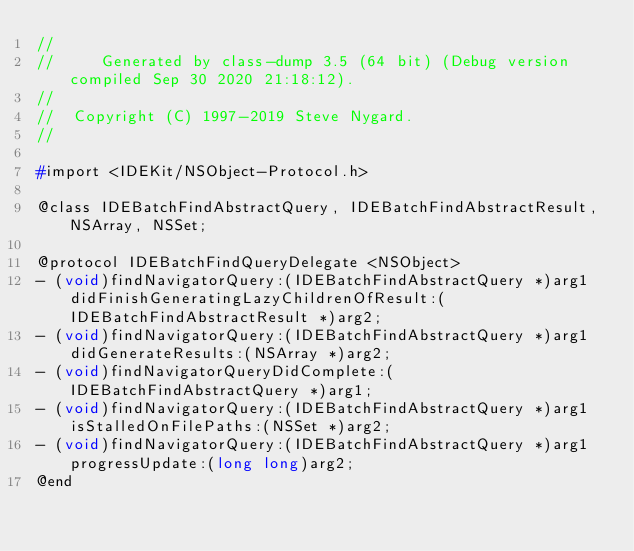Convert code to text. <code><loc_0><loc_0><loc_500><loc_500><_C_>//
//     Generated by class-dump 3.5 (64 bit) (Debug version compiled Sep 30 2020 21:18:12).
//
//  Copyright (C) 1997-2019 Steve Nygard.
//

#import <IDEKit/NSObject-Protocol.h>

@class IDEBatchFindAbstractQuery, IDEBatchFindAbstractResult, NSArray, NSSet;

@protocol IDEBatchFindQueryDelegate <NSObject>
- (void)findNavigatorQuery:(IDEBatchFindAbstractQuery *)arg1 didFinishGeneratingLazyChildrenOfResult:(IDEBatchFindAbstractResult *)arg2;
- (void)findNavigatorQuery:(IDEBatchFindAbstractQuery *)arg1 didGenerateResults:(NSArray *)arg2;
- (void)findNavigatorQueryDidComplete:(IDEBatchFindAbstractQuery *)arg1;
- (void)findNavigatorQuery:(IDEBatchFindAbstractQuery *)arg1 isStalledOnFilePaths:(NSSet *)arg2;
- (void)findNavigatorQuery:(IDEBatchFindAbstractQuery *)arg1 progressUpdate:(long long)arg2;
@end

</code> 